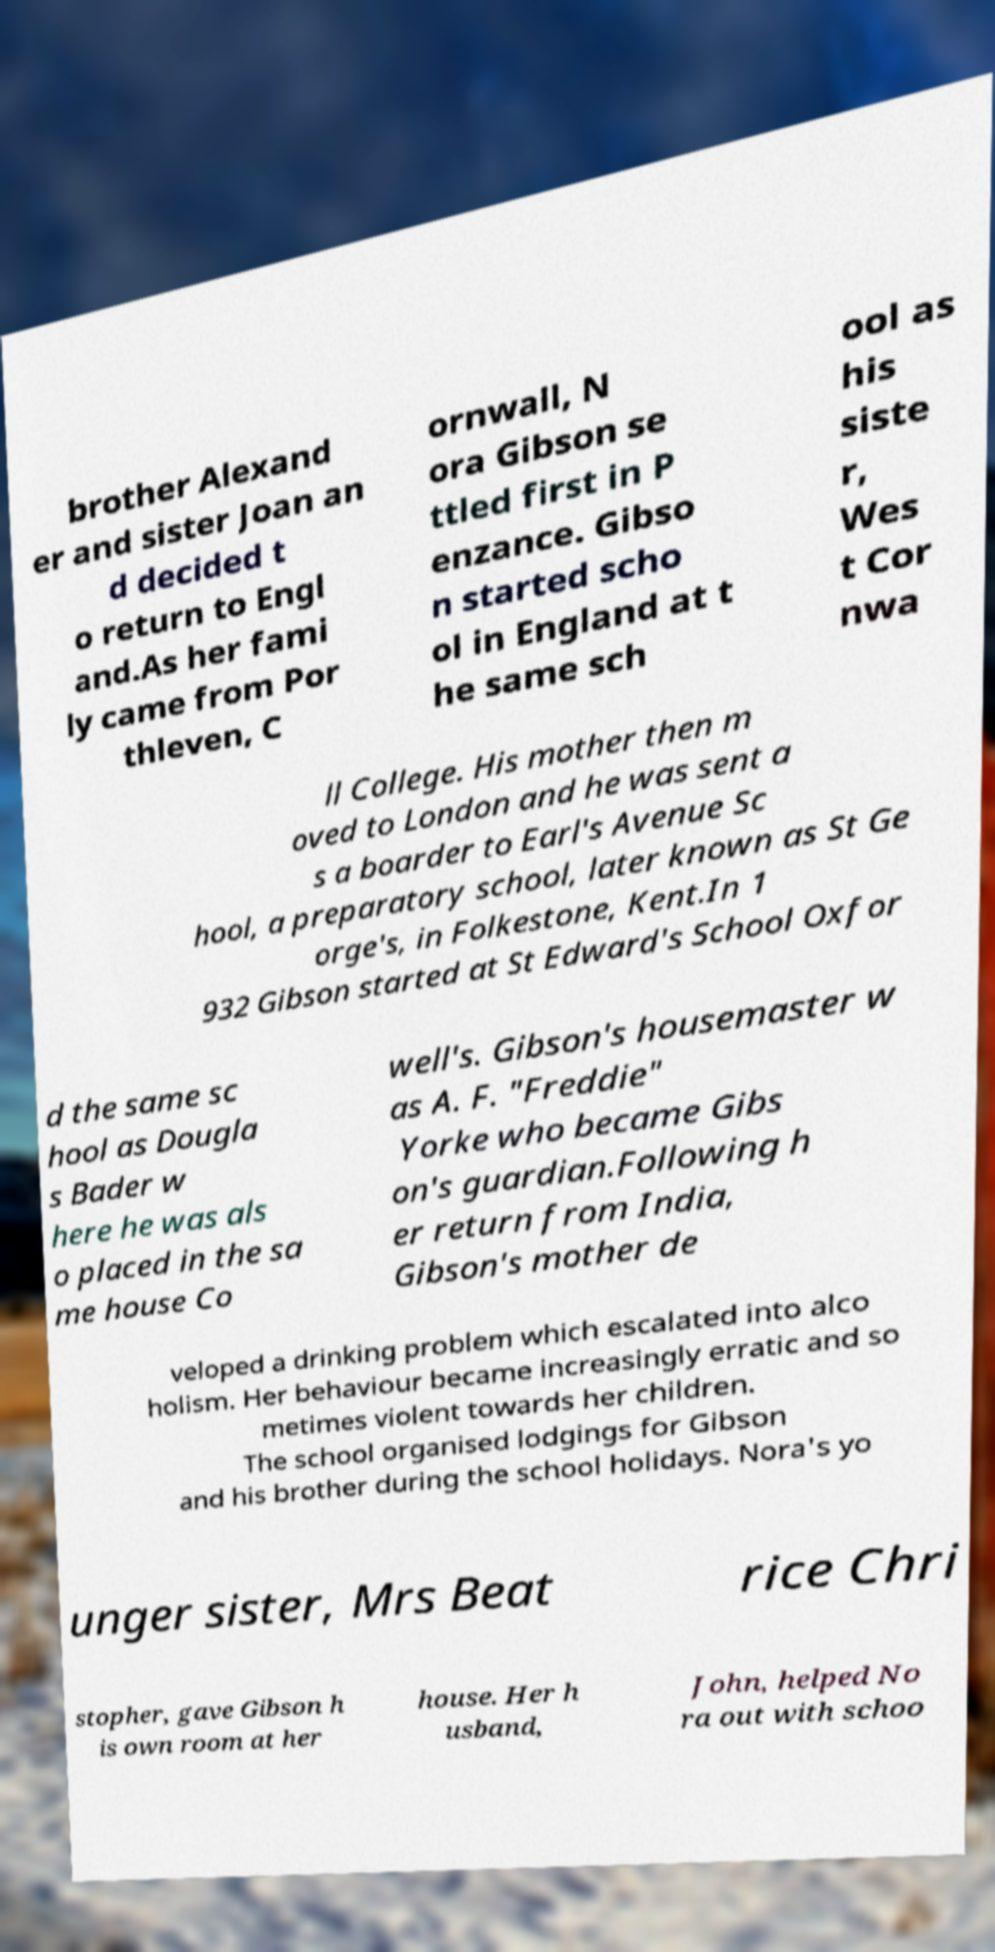Can you accurately transcribe the text from the provided image for me? brother Alexand er and sister Joan an d decided t o return to Engl and.As her fami ly came from Por thleven, C ornwall, N ora Gibson se ttled first in P enzance. Gibso n started scho ol in England at t he same sch ool as his siste r, Wes t Cor nwa ll College. His mother then m oved to London and he was sent a s a boarder to Earl's Avenue Sc hool, a preparatory school, later known as St Ge orge's, in Folkestone, Kent.In 1 932 Gibson started at St Edward's School Oxfor d the same sc hool as Dougla s Bader w here he was als o placed in the sa me house Co well's. Gibson's housemaster w as A. F. "Freddie" Yorke who became Gibs on's guardian.Following h er return from India, Gibson's mother de veloped a drinking problem which escalated into alco holism. Her behaviour became increasingly erratic and so metimes violent towards her children. The school organised lodgings for Gibson and his brother during the school holidays. Nora's yo unger sister, Mrs Beat rice Chri stopher, gave Gibson h is own room at her house. Her h usband, John, helped No ra out with schoo 